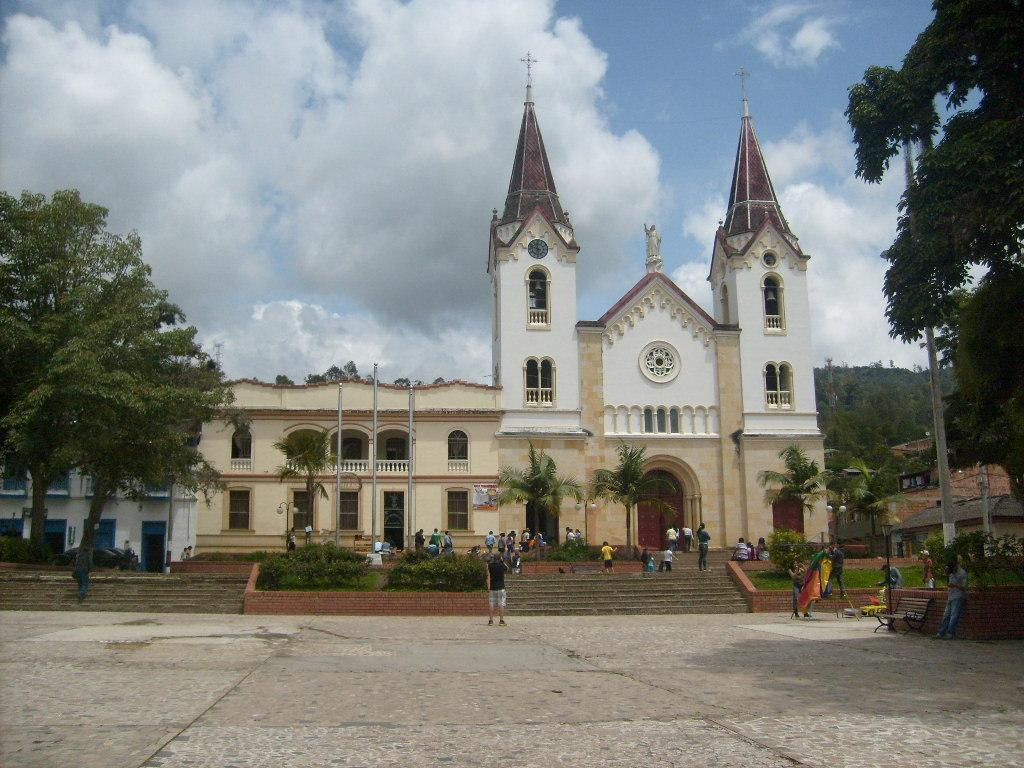What type of structure is visible in the image? There is a building in the image. What feature of the building is mentioned in the facts? The building has windows. What architectural element can be seen in the image? There are stairs in the image. What type of vegetation is present in the image? There are trees in the image. What type of seating is available in the image? There is a bench in the image. What type of lighting is present in the image? There are light poles in the image. Are there any people visible in the image? Yes, there are people in the image. What is the color of the sky in the image? The sky is blue and white in color. How much knowledge can be gained from the square in the image? There is no square present in the image, so it is not possible to gain knowledge from it. 